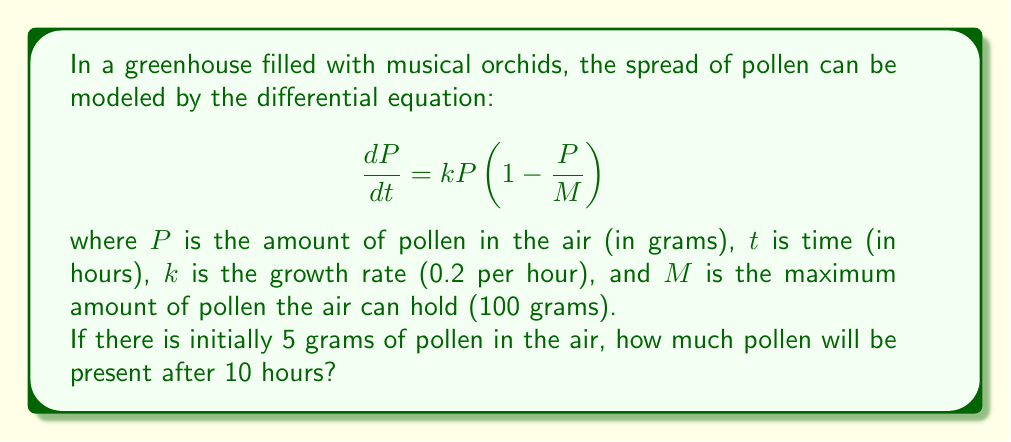Provide a solution to this math problem. To solve this problem, we need to use the logistic growth model, which is represented by the given differential equation. Let's follow these steps:

1) First, we need to separate variables and integrate both sides:

   $$\int \frac{dP}{P(1-\frac{P}{M})} = \int k dt$$

2) The left side can be integrated using partial fractions:

   $$\frac{1}{M} \ln(\frac{P}{M-P}) = kt + C$$

3) Solving for $P$:

   $$P = \frac{M}{1 + Ce^{-kMt}}$$

4) Now we can use the initial condition to find $C$. At $t=0$, $P=5$:

   $$5 = \frac{100}{1 + C}$$

   Solving this, we get $C = 19$

5) So our particular solution is:

   $$P = \frac{100}{1 + 19e^{-20t}}$$

6) To find $P$ at $t=10$, we simply plug in $t=10$:

   $$P(10) = \frac{100}{1 + 19e^{-20(10)}}$$

7) Calculating this (you may use a calculator):

   $$P(10) \approx 90.74$$

Therefore, after 10 hours, there will be approximately 90.74 grams of pollen in the air.
Answer: $90.74$ grams of pollen (rounded to two decimal places) 